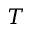Convert formula to latex. <formula><loc_0><loc_0><loc_500><loc_500>T</formula> 